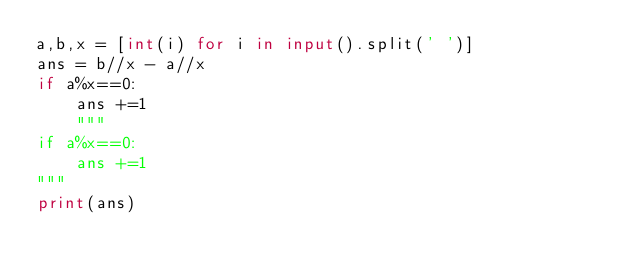<code> <loc_0><loc_0><loc_500><loc_500><_Python_>a,b,x = [int(i) for i in input().split(' ')]
ans = b//x - a//x
if a%x==0:
    ans +=1
    """
if a%x==0:
    ans +=1
"""
print(ans)
</code> 